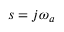Convert formula to latex. <formula><loc_0><loc_0><loc_500><loc_500>s = j \omega _ { a }</formula> 